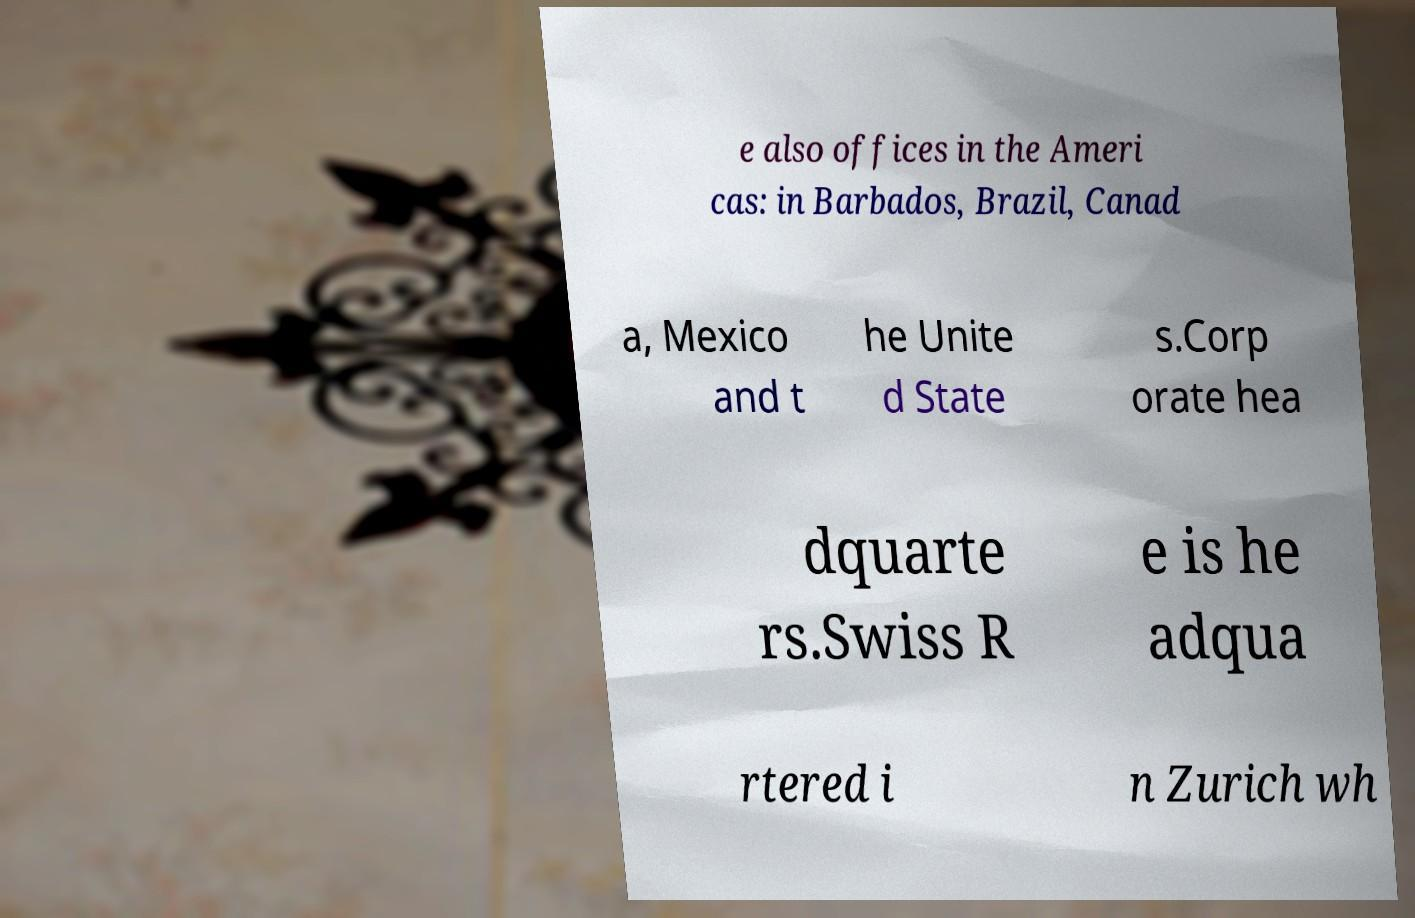I need the written content from this picture converted into text. Can you do that? e also offices in the Ameri cas: in Barbados, Brazil, Canad a, Mexico and t he Unite d State s.Corp orate hea dquarte rs.Swiss R e is he adqua rtered i n Zurich wh 